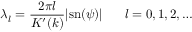Convert formula to latex. <formula><loc_0><loc_0><loc_500><loc_500>\lambda _ { l } = \frac { 2 \pi l } { K ^ { \prime } ( k ) } | s n ( \psi ) | \, l = 0 , 1 , 2 , \dots</formula> 